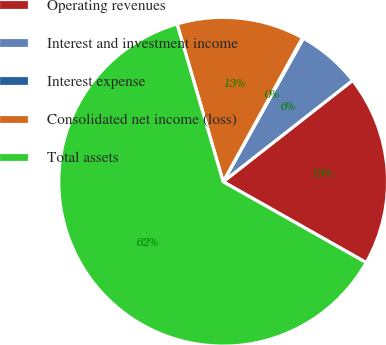<chart> <loc_0><loc_0><loc_500><loc_500><pie_chart><fcel>Operating revenues<fcel>Interest and investment income<fcel>Interest expense<fcel>Consolidated net income (loss)<fcel>Total assets<nl><fcel>18.76%<fcel>6.32%<fcel>0.1%<fcel>12.54%<fcel>62.29%<nl></chart> 